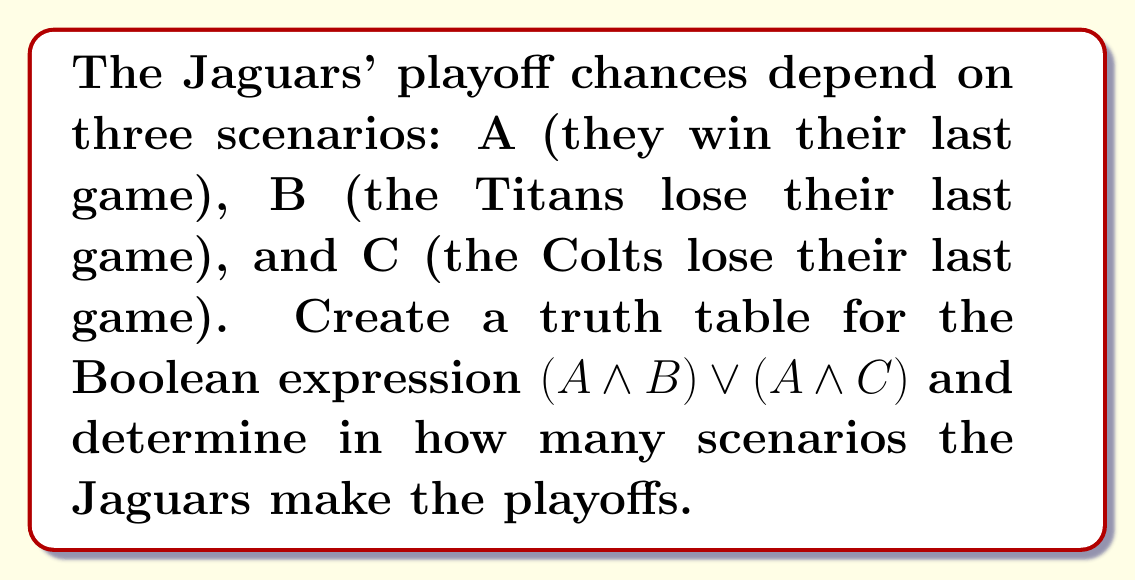Help me with this question. Let's approach this step-by-step:

1) First, we need to create a truth table for the given Boolean expression: $(A \land B) \lor (A \land C)$

2) The truth table will have 8 rows (2^3 = 8, as we have 3 variables):

   | A | B | C | $A \land B$ | $A \land C$ | $(A \land B) \lor (A \land C)$ |
   |---|---|---|-------------|-------------|--------------------------------|
   | 0 | 0 | 0 |      0      |      0      |               0                |
   | 0 | 0 | 1 |      0      |      0      |               0                |
   | 0 | 1 | 0 |      0      |      0      |               0                |
   | 0 | 1 | 1 |      0      |      0      |               0                |
   | 1 | 0 | 0 |      0      |      0      |               0                |
   | 1 | 0 | 1 |      0      |      1      |               1                |
   | 1 | 1 | 0 |      1      |      0      |               1                |
   | 1 | 1 | 1 |      1      |      1      |               1                |

3) Now, we need to count the number of rows where the final column ($(A \land B) \lor (A \land C)$) is 1. This represents the scenarios where the Jaguars make the playoffs.

4) From the truth table, we can see that there are 3 rows where the final column is 1.

Therefore, there are 3 scenarios where the Jaguars make the playoffs according to this Boolean expression.
Answer: 3 scenarios 